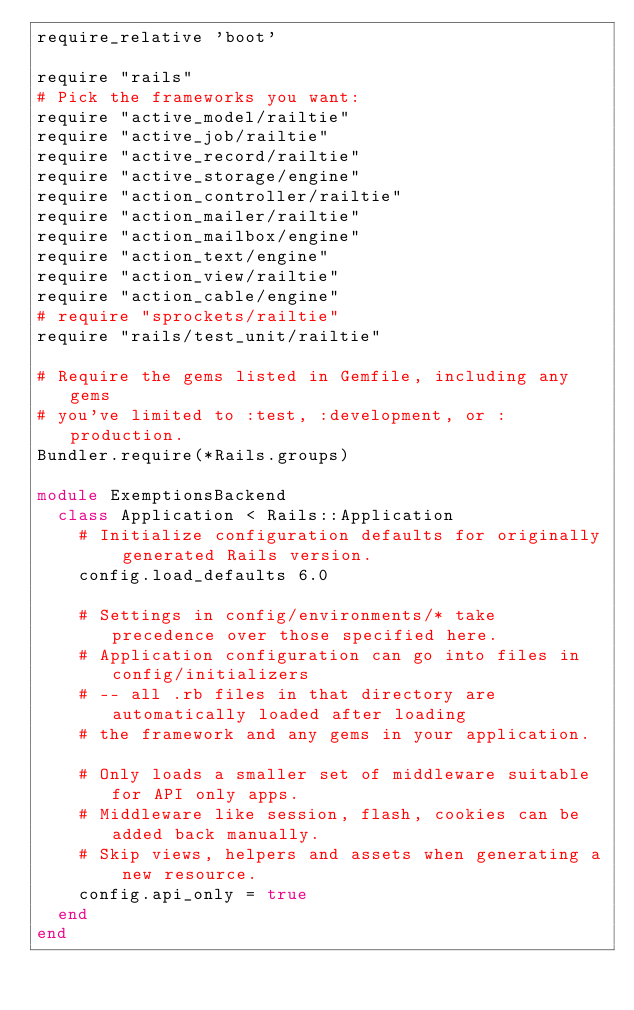<code> <loc_0><loc_0><loc_500><loc_500><_Ruby_>require_relative 'boot'

require "rails"
# Pick the frameworks you want:
require "active_model/railtie"
require "active_job/railtie"
require "active_record/railtie"
require "active_storage/engine"
require "action_controller/railtie"
require "action_mailer/railtie"
require "action_mailbox/engine"
require "action_text/engine"
require "action_view/railtie"
require "action_cable/engine"
# require "sprockets/railtie"
require "rails/test_unit/railtie"

# Require the gems listed in Gemfile, including any gems
# you've limited to :test, :development, or :production.
Bundler.require(*Rails.groups)

module ExemptionsBackend
  class Application < Rails::Application
    # Initialize configuration defaults for originally generated Rails version.
    config.load_defaults 6.0

    # Settings in config/environments/* take precedence over those specified here.
    # Application configuration can go into files in config/initializers
    # -- all .rb files in that directory are automatically loaded after loading
    # the framework and any gems in your application.

    # Only loads a smaller set of middleware suitable for API only apps.
    # Middleware like session, flash, cookies can be added back manually.
    # Skip views, helpers and assets when generating a new resource.
    config.api_only = true
  end
end
</code> 